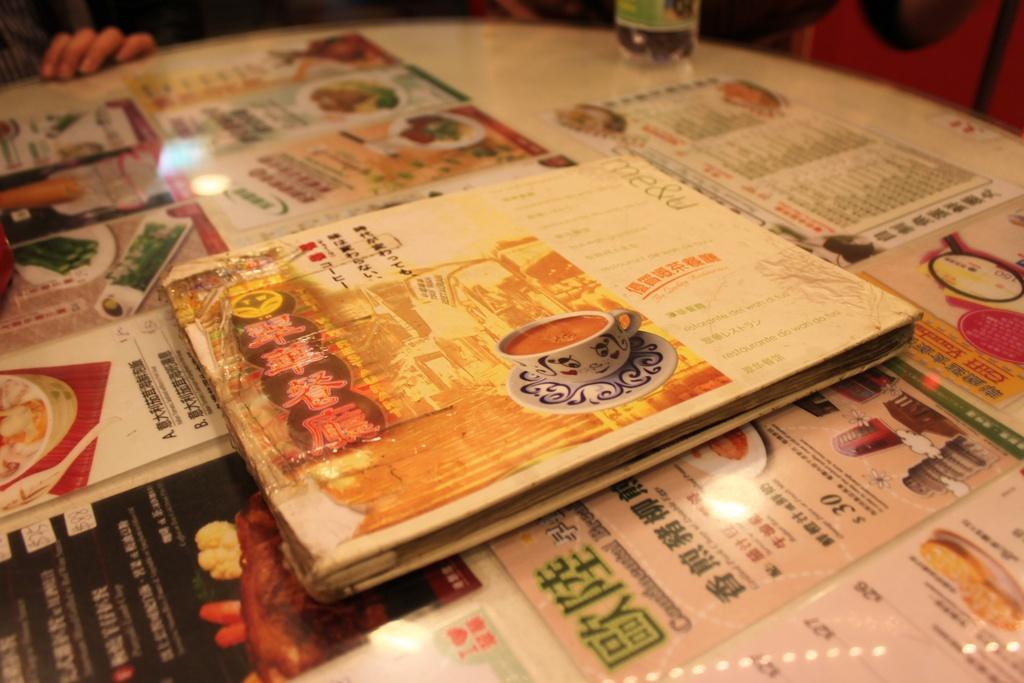<image>
Present a compact description of the photo's key features. Chinese writing is on the front of the menu 